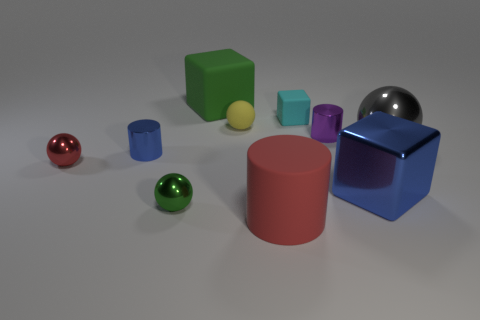Subtract all spheres. How many objects are left? 6 Add 5 small cyan matte blocks. How many small cyan matte blocks are left? 6 Add 5 tiny cyan rubber things. How many tiny cyan rubber things exist? 6 Subtract 0 yellow cylinders. How many objects are left? 10 Subtract all blue blocks. Subtract all big gray metallic balls. How many objects are left? 8 